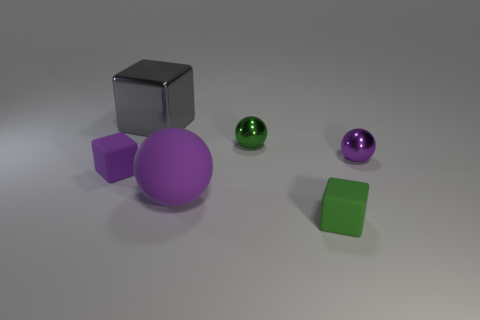Subtract all tiny green blocks. How many blocks are left? 2 Add 4 big gray shiny blocks. How many objects exist? 10 Subtract all green spheres. How many spheres are left? 2 Subtract 3 blocks. How many blocks are left? 0 Subtract 1 gray blocks. How many objects are left? 5 Subtract all cyan balls. Subtract all blue cylinders. How many balls are left? 3 Subtract all brown blocks. How many purple balls are left? 2 Subtract all large cyan rubber objects. Subtract all purple metallic objects. How many objects are left? 5 Add 2 purple shiny things. How many purple shiny things are left? 3 Add 6 red shiny blocks. How many red shiny blocks exist? 6 